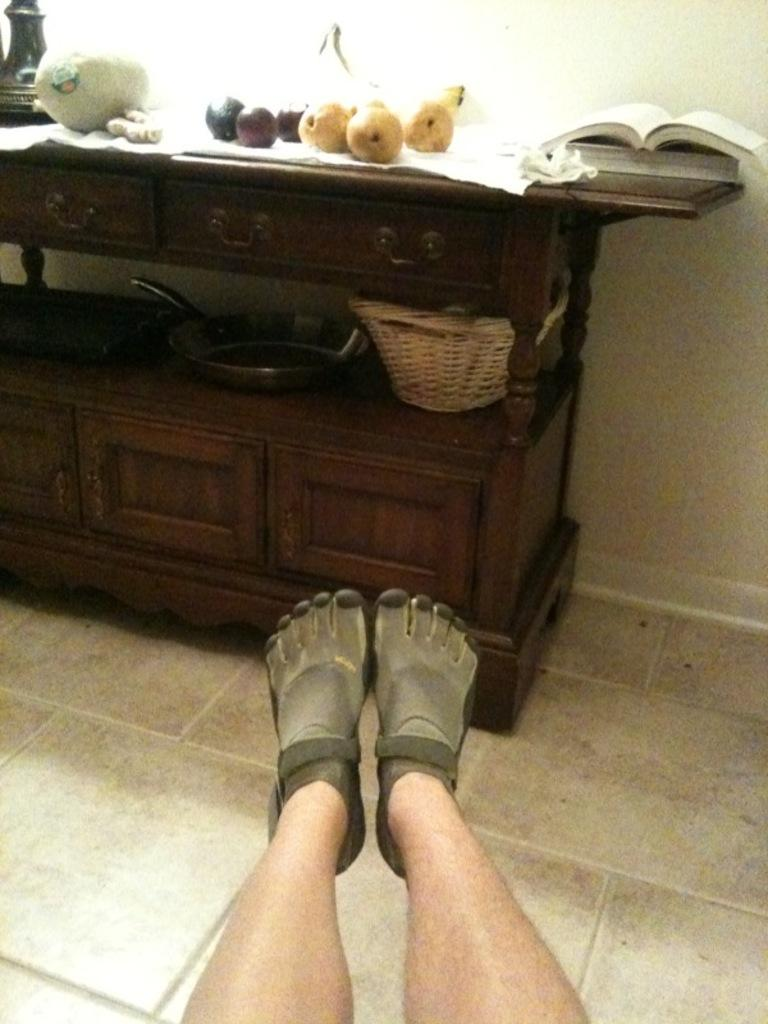What body part is visible in the image? There are a person's legs in the image. What piece of furniture is present in the image? There is a table in the image. What items can be seen on the table? The table has fruits and a book on it, as well as other objects. What is visible behind the table? There is a wall visible in the image. What type of goose is sitting on the person's lap in the image? There is no goose present in the image; only a person's legs, a table, and various objects are visible. 